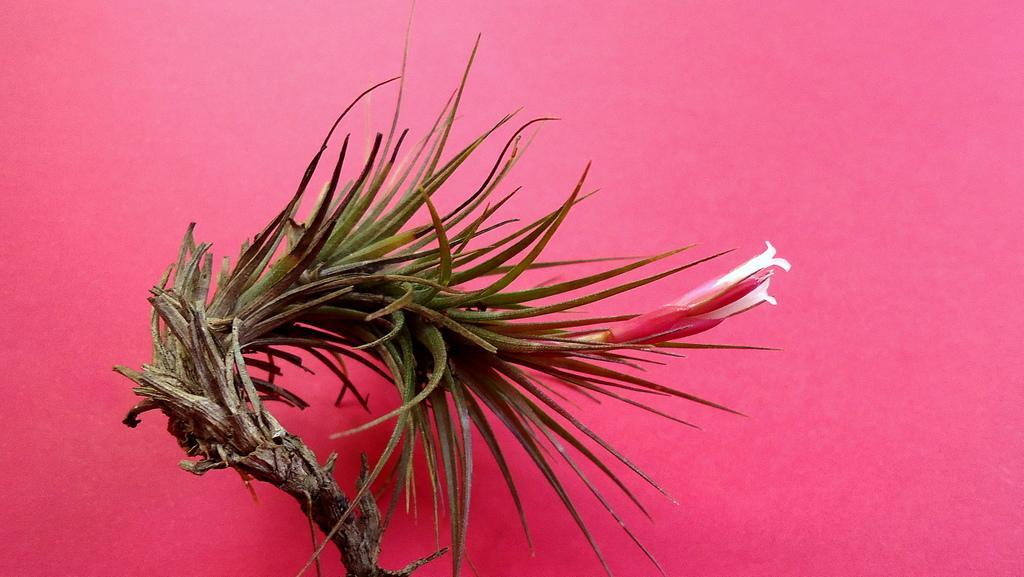How would you summarize this image in a sentence or two? In this picture I can see the pink color surface, on which there is a brown color thing and I see white and red color thing on it. 